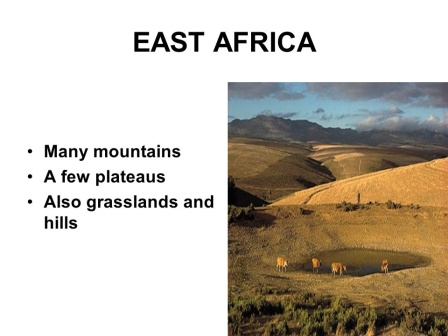Can you describe a realistic scenario where a conservationist is working to protect the elephants in the image? In a realistic scenario, a conservationist working in this region is dedicated to protecting the majestic elephants roaming the grasslands. They begin their day at dawn, joining a team of local rangers equipped with GPS tracking devices and cameras to monitor the elephants. Their work involves studying the movements and behavior of these gentle giants to understand their migratory patterns and habitat needs. The conservationist engages with the local communities, educating them about the importance of elephant conservation and promoting human-wildlife coexistence. On patrol, they investigate signs of illegal activities like poaching or habitat destruction, working tirelessly to prevent such incidents. Collaboration with international wildlife organizations allows them to secure funding and resources for anti-poaching measures and habitat restoration projects. The day ends with data analysis, logging their findings into a database to inform future conservation strategies. Through their efforts, they aim to ensure that these elephants continue to thrive in their natural habitat. 